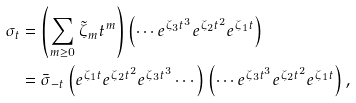Convert formula to latex. <formula><loc_0><loc_0><loc_500><loc_500>\sigma _ { t } & = \left ( \sum _ { m \geq 0 } \tilde { \zeta } _ { m } t ^ { m } \right ) \left ( \cdots e ^ { \zeta _ { 3 } t ^ { 3 } } e ^ { \zeta _ { 2 } t ^ { 2 } } e ^ { \zeta _ { 1 } t } \right ) \\ & = \bar { \sigma } _ { - t } \left ( e ^ { \zeta _ { 1 } t } e ^ { \zeta _ { 2 } t ^ { 2 } } e ^ { \zeta _ { 3 } t ^ { 3 } } \cdots \right ) \left ( \cdots e ^ { \zeta _ { 3 } t ^ { 3 } } e ^ { \zeta _ { 2 } t ^ { 2 } } e ^ { \zeta _ { 1 } t } \right ) ,</formula> 